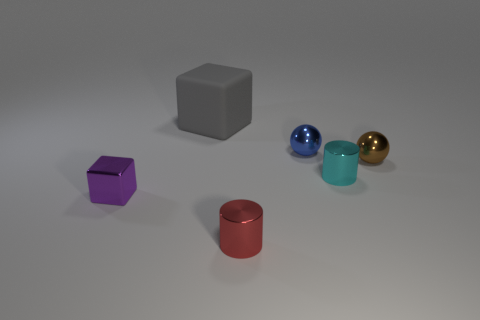How many large cubes are behind the small cylinder behind the thing left of the gray object?
Make the answer very short. 1. How many things are both to the left of the tiny cyan metal thing and to the right of the small blue sphere?
Offer a terse response. 0. Are there more tiny red things in front of the matte cube than cyan metallic things?
Your answer should be compact. No. How many brown metallic objects have the same size as the purple cube?
Offer a terse response. 1. What number of small objects are gray blocks or blue spheres?
Your answer should be compact. 1. How many tiny blue metal spheres are there?
Your response must be concise. 1. Are there an equal number of shiny cylinders behind the tiny red shiny object and small blue objects in front of the tiny blue thing?
Make the answer very short. No. There is a matte object; are there any metal balls behind it?
Keep it short and to the point. No. There is a cube that is to the left of the large gray object; what color is it?
Your answer should be very brief. Purple. What is the thing on the left side of the block that is behind the tiny purple thing made of?
Your response must be concise. Metal. 